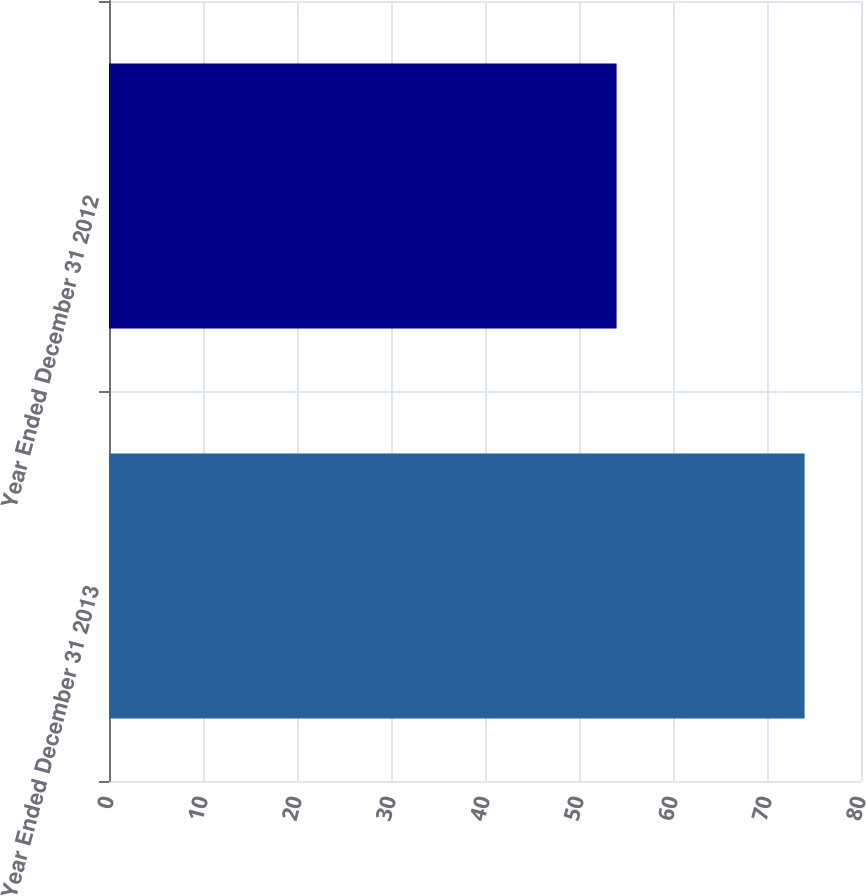Convert chart to OTSL. <chart><loc_0><loc_0><loc_500><loc_500><bar_chart><fcel>Year Ended December 31 2013<fcel>Year Ended December 31 2012<nl><fcel>74<fcel>54<nl></chart> 